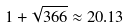<formula> <loc_0><loc_0><loc_500><loc_500>1 + \sqrt { 3 6 6 } \approx 2 0 . 1 3</formula> 